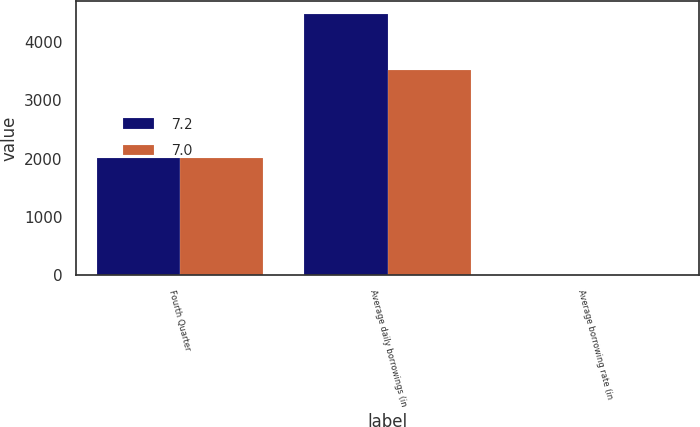<chart> <loc_0><loc_0><loc_500><loc_500><stacked_bar_chart><ecel><fcel>Fourth Quarter<fcel>Average daily borrowings (in<fcel>Average borrowing rate (in<nl><fcel>7.2<fcel>2012<fcel>4484<fcel>7<nl><fcel>7<fcel>2011<fcel>3520<fcel>7.2<nl></chart> 